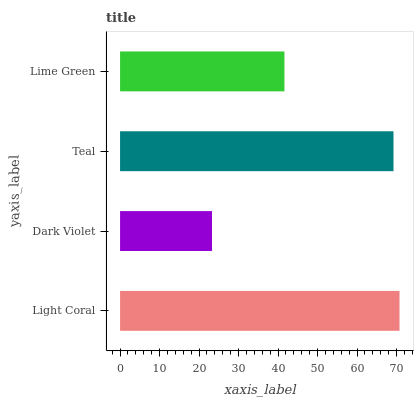Is Dark Violet the minimum?
Answer yes or no. Yes. Is Light Coral the maximum?
Answer yes or no. Yes. Is Teal the minimum?
Answer yes or no. No. Is Teal the maximum?
Answer yes or no. No. Is Teal greater than Dark Violet?
Answer yes or no. Yes. Is Dark Violet less than Teal?
Answer yes or no. Yes. Is Dark Violet greater than Teal?
Answer yes or no. No. Is Teal less than Dark Violet?
Answer yes or no. No. Is Teal the high median?
Answer yes or no. Yes. Is Lime Green the low median?
Answer yes or no. Yes. Is Lime Green the high median?
Answer yes or no. No. Is Dark Violet the low median?
Answer yes or no. No. 